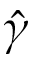Convert formula to latex. <formula><loc_0><loc_0><loc_500><loc_500>\hat { \gamma }</formula> 